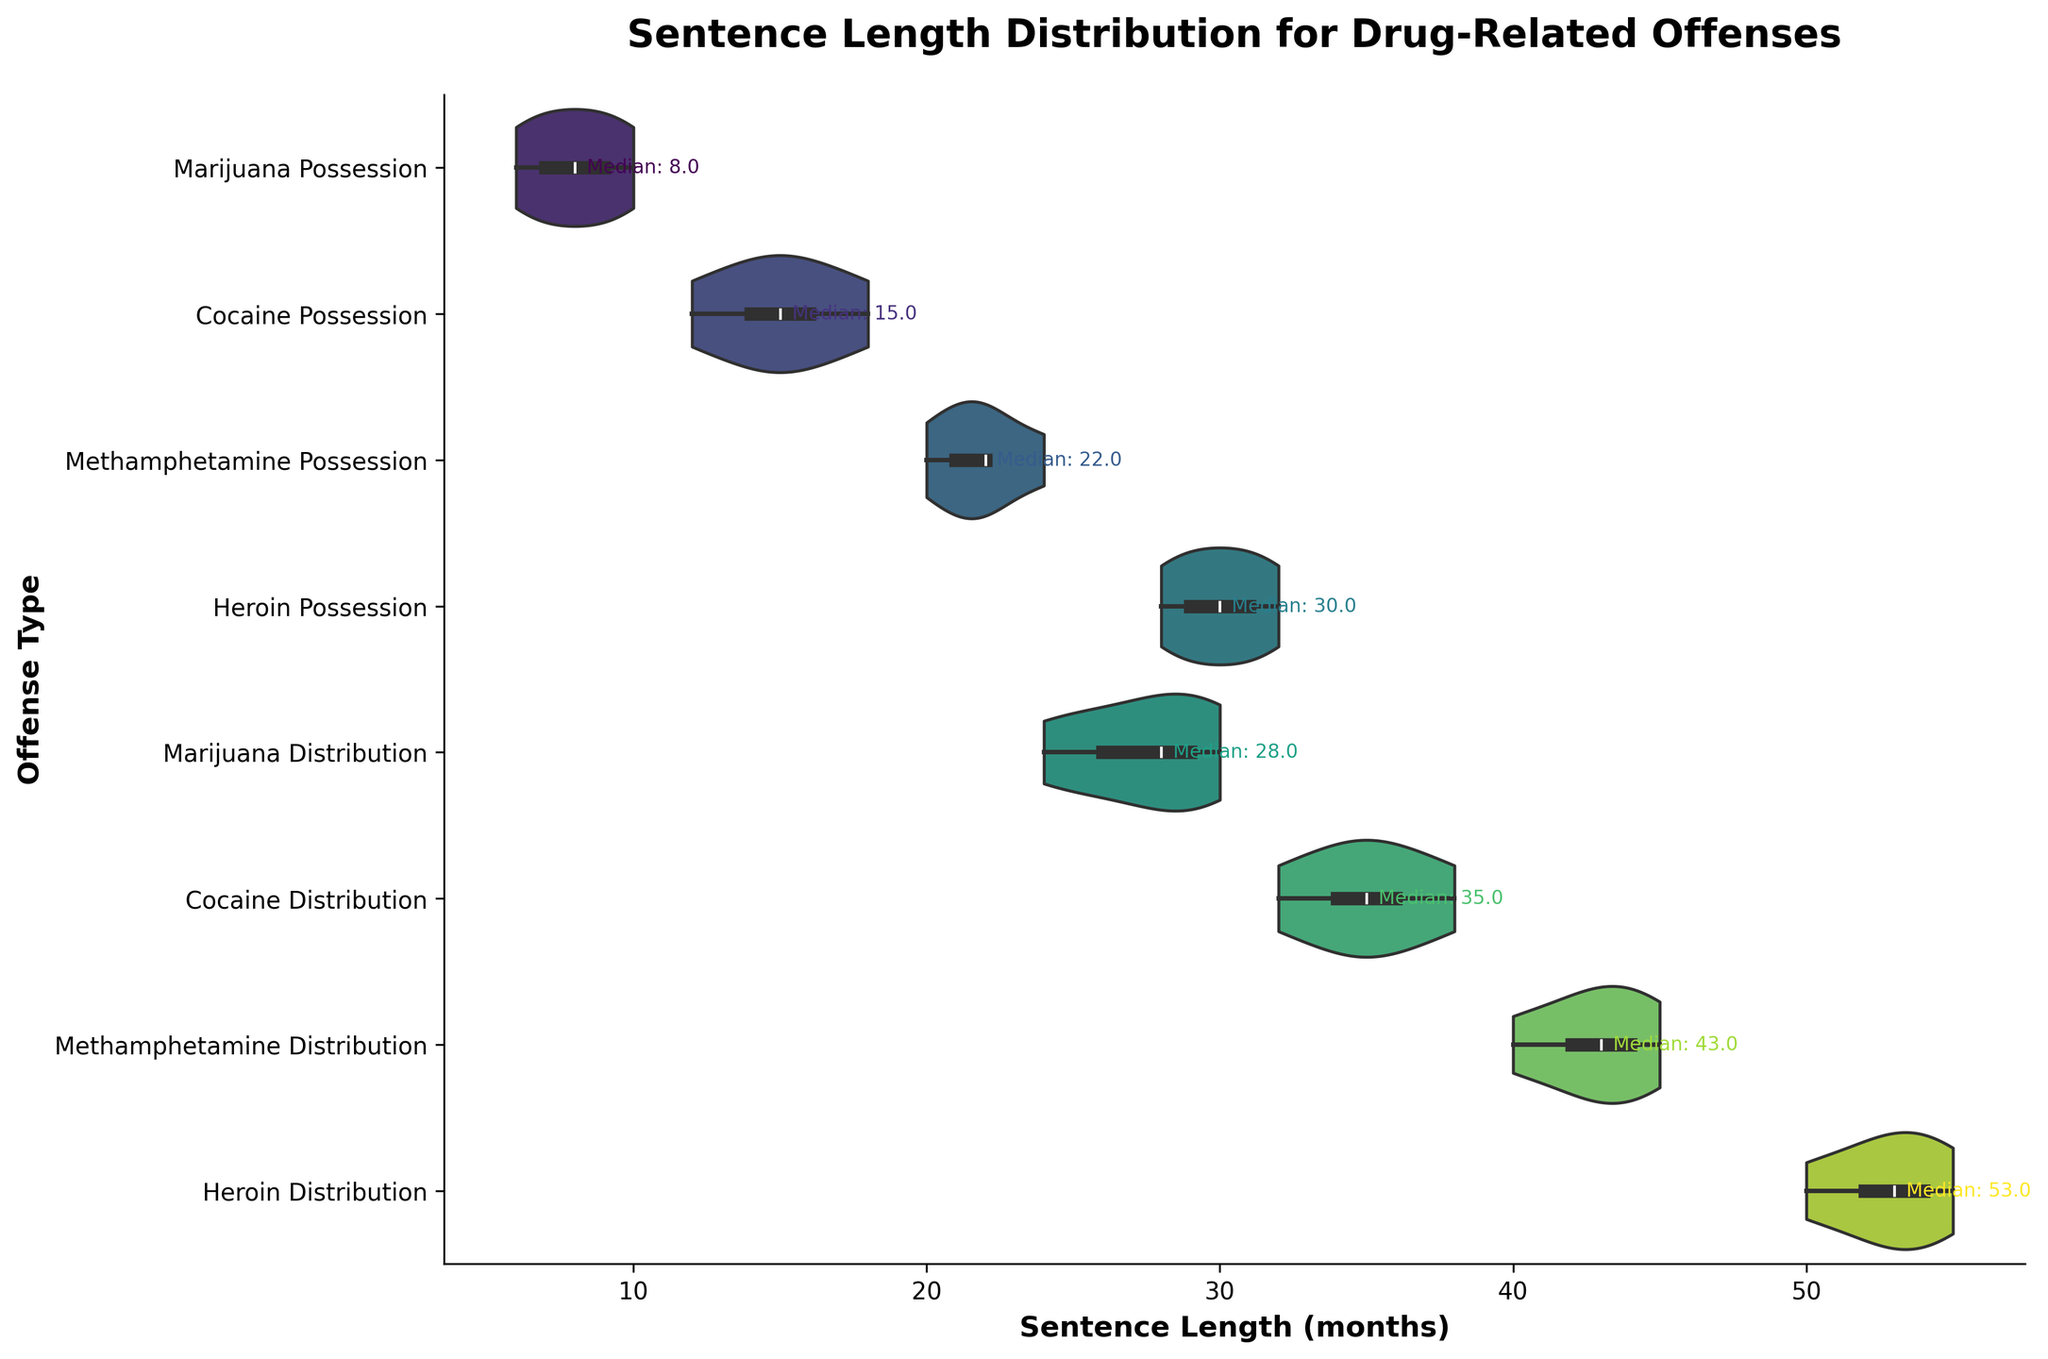What are the offense types shown in the figure? The figure lists all the offense types on the y-axis. By looking at the y-axis values, we can identify the offense types included in the chart.
Answer: Marijuana Possession, Cocaine Possession, Methamphetamine Possession, Heroin Possession, Marijuana Distribution, Cocaine Distribution, Methamphetamine Distribution, Heroin Distribution What is the title of the figure? The title is written at the top of the chart. By reading that text, we can identify the title of the figure.
Answer: Sentence Length Distribution for Drug-Related Offenses Which offense type has the shortest median sentence length? The median sentence length for each offense type can be seen in the text annotations on the figure. The offense type with the smallest median value will have the shortest median sentence length.
Answer: Marijuana Possession Which offense type has the widest range of sentence lengths? By observing the horizontal span of the violins, we can determine the range of sentence lengths. The offense with the widest segment has the largest range.
Answer: Heroin Distribution What is the median sentence length for Cocaine Possession? The median sentence length is annotated directly on the graph. By locating the label for Cocaine Possession, we can read the median value.
Answer: 15 months How does the median sentence length for Methamphetamine Possession compare to Heroin Possession? Compare the annotated median values for both Methamphetamine and Heroin Possession.
Answer: Methamphetamine Possession has a shorter median sentence length than Heroin Possession What is the general shape of the violin plots for Marijuana Distribution and Heroin Distribution? By observing the violin plots, we can describe their shapes, focusing on width variations and symmetry.
Answer: Both violins are wide in the middle and taper towards the ends, indicating a higher density of sentences around the median How do the medians of the possession offenses compare to each other? Compare the annotated median values for all possession offenses (Marijuana, Cocaine, Methamphetamine, Heroin). Identify the one that is the smallest and the one that is the largest.
Answer: Marijuana Possession has the smallest median while Heroin Possession has the largest What can you infer about sentence lengths for drug distribution compared to possession? Compare the general placement and median values of the distribution offenses with the possession offenses. Distribution offenses appear to have longer sentence lengths on average.
Answer: Distribution offenses tend to have longer sentence lengths than possession offenses How do the sentence distributions for Marijuana Possession and Cocaine Possession compare? Compare the shapes, ranges, and median annotations of the two violin plots for Marijuana Possession and Cocaine Possession.
Answer: Cocaine Possession has a higher median sentence length and a wider distribution compared to Marijuana Possession 